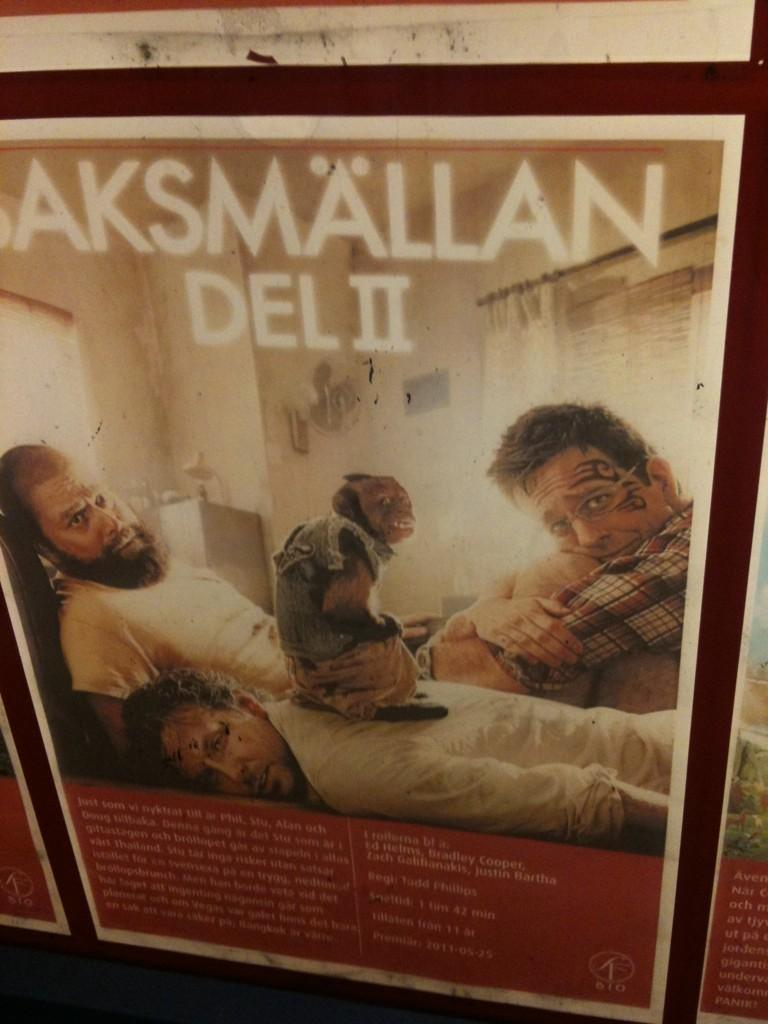What is depicted on the wall poster in the image? The wall poster features three men. What can be seen in the background of the poster? There is a wall visible in the poster. Are there any words or phrases on the poster? Yes, there is text present in the poster. Can you tell me how many kittens are playing on the slope in the image? There are no kittens or slopes present in the image; it features a wall poster with three men. 